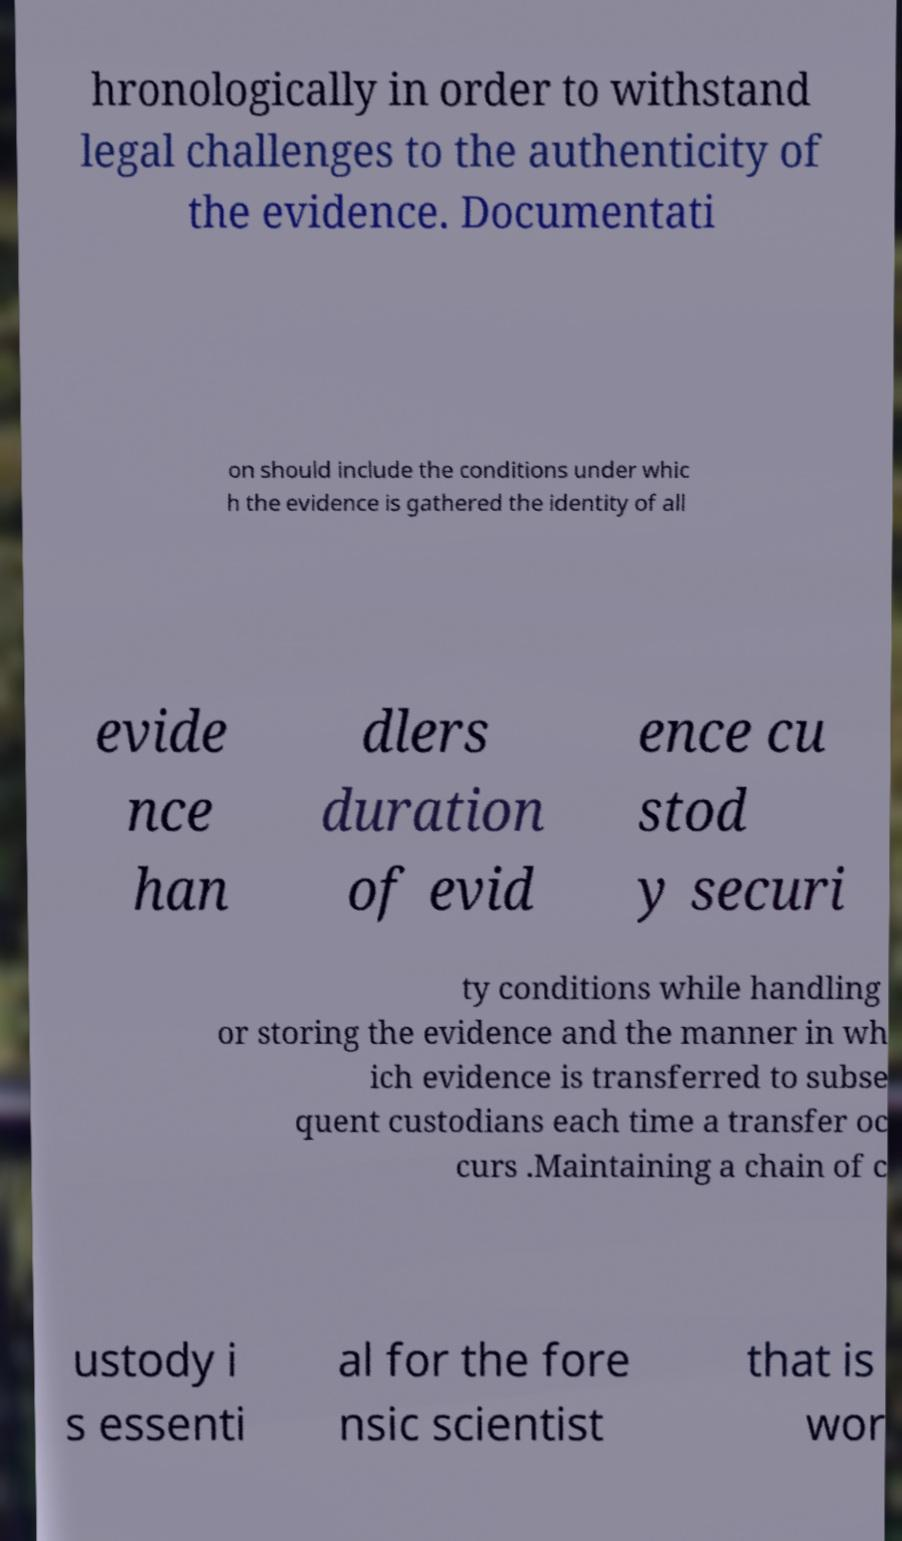Could you extract and type out the text from this image? hronologically in order to withstand legal challenges to the authenticity of the evidence. Documentati on should include the conditions under whic h the evidence is gathered the identity of all evide nce han dlers duration of evid ence cu stod y securi ty conditions while handling or storing the evidence and the manner in wh ich evidence is transferred to subse quent custodians each time a transfer oc curs .Maintaining a chain of c ustody i s essenti al for the fore nsic scientist that is wor 